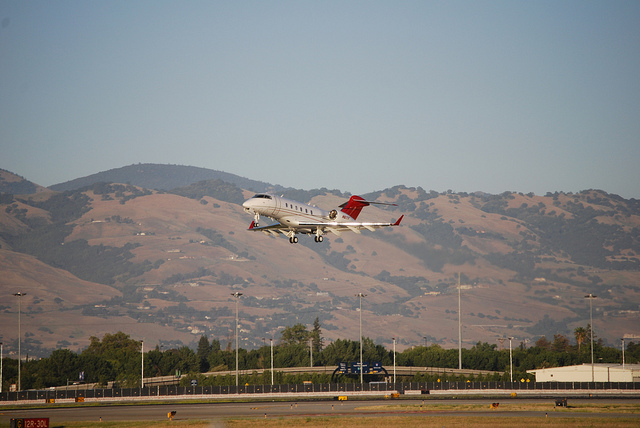<image>What is the white speck in the sky? I don't know what the white speck in the sky is. It could be a plane, a cloud, or even photo debris. What is the white speck in the sky? I don't know what the white speck in the sky is. It can be a plane, cloud, airplane, or photo debris. 